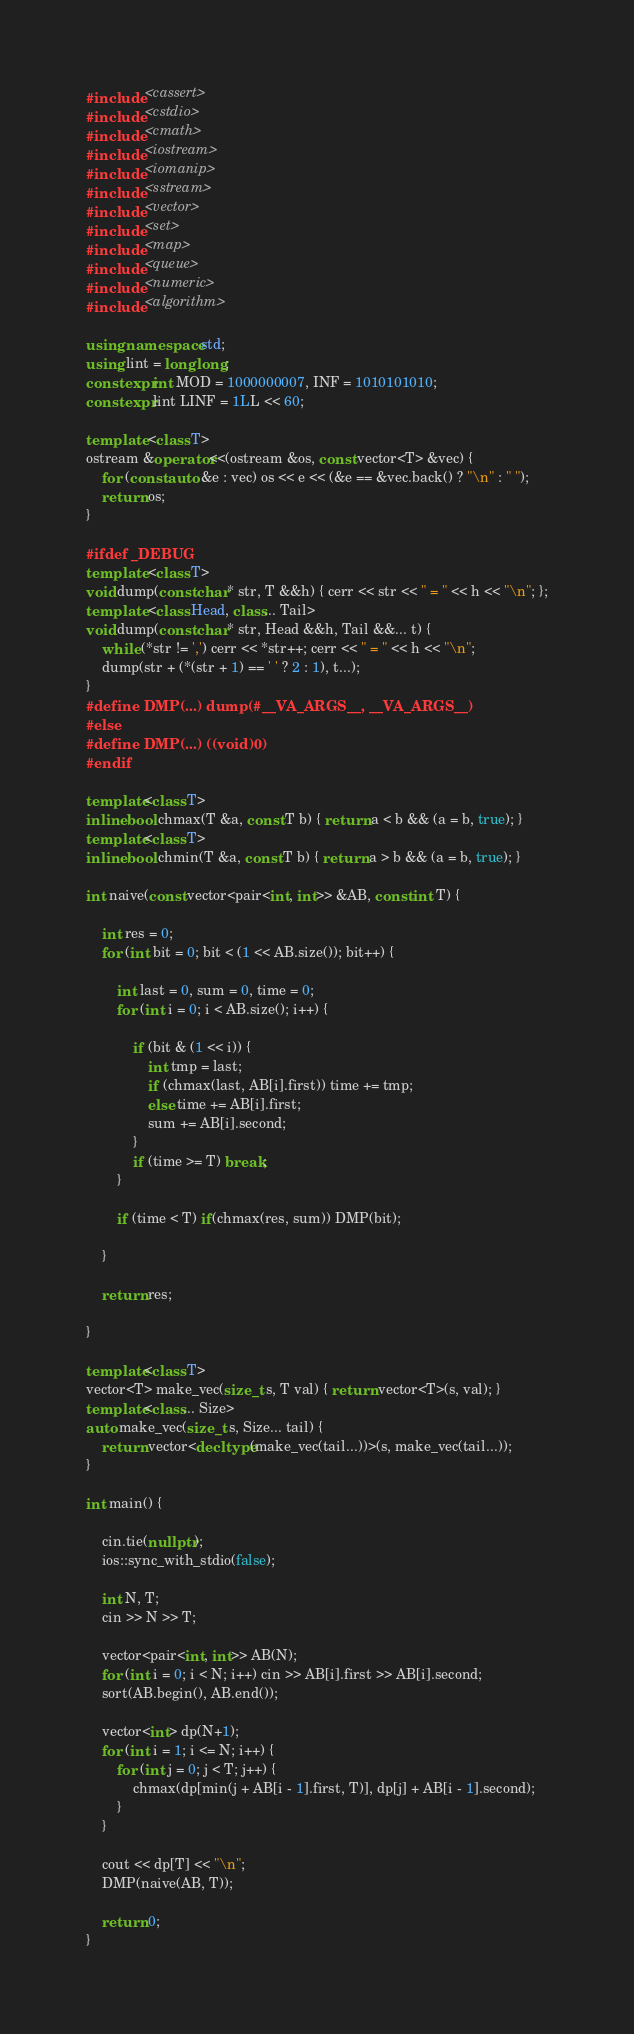<code> <loc_0><loc_0><loc_500><loc_500><_C++_>#include <cassert>
#include <cstdio>
#include <cmath>
#include <iostream>
#include <iomanip>
#include <sstream>
#include <vector>
#include <set>
#include <map>
#include <queue>
#include <numeric>
#include <algorithm>

using namespace std;
using lint = long long;
constexpr int MOD = 1000000007, INF = 1010101010;
constexpr lint LINF = 1LL << 60;

template <class T>
ostream &operator<<(ostream &os, const vector<T> &vec) {
	for (const auto &e : vec) os << e << (&e == &vec.back() ? "\n" : " ");
	return os;
}

#ifdef _DEBUG
template <class T>
void dump(const char* str, T &&h) { cerr << str << " = " << h << "\n"; };
template <class Head, class... Tail>
void dump(const char* str, Head &&h, Tail &&... t) {
	while (*str != ',') cerr << *str++; cerr << " = " << h << "\n";
	dump(str + (*(str + 1) == ' ' ? 2 : 1), t...);
}
#define DMP(...) dump(#__VA_ARGS__, __VA_ARGS__)
#else 
#define DMP(...) ((void)0)
#endif

template<class T>
inline bool chmax(T &a, const T b) { return a < b && (a = b, true); }
template<class T>
inline bool chmin(T &a, const T b) { return a > b && (a = b, true); }

int naive(const vector<pair<int, int>> &AB, const int T) {

	int res = 0;
	for (int bit = 0; bit < (1 << AB.size()); bit++) {

		int last = 0, sum = 0, time = 0;
		for (int i = 0; i < AB.size(); i++) {

			if (bit & (1 << i)) {
				int tmp = last;
				if (chmax(last, AB[i].first)) time += tmp;
				else time += AB[i].first;
				sum += AB[i].second;
			}
			if (time >= T) break;
		}

		if (time < T) if(chmax(res, sum)) DMP(bit);

	}

	return res;

}

template<class T>
vector<T> make_vec(size_t s, T val) { return vector<T>(s, val); }
template<class... Size>
auto make_vec(size_t s, Size... tail) {
	return vector<decltype(make_vec(tail...))>(s, make_vec(tail...));
}

int main() {

	cin.tie(nullptr);
	ios::sync_with_stdio(false);

	int N, T;
	cin >> N >> T;

	vector<pair<int, int>> AB(N);
	for (int i = 0; i < N; i++) cin >> AB[i].first >> AB[i].second;
	sort(AB.begin(), AB.end());
	
	vector<int> dp(N+1);
	for (int i = 1; i <= N; i++) {
		for (int j = 0; j < T; j++) {
			chmax(dp[min(j + AB[i - 1].first, T)], dp[j] + AB[i - 1].second);
		}
	}
	
	cout << dp[T] << "\n";
	DMP(naive(AB, T));

	return 0;
}
</code> 